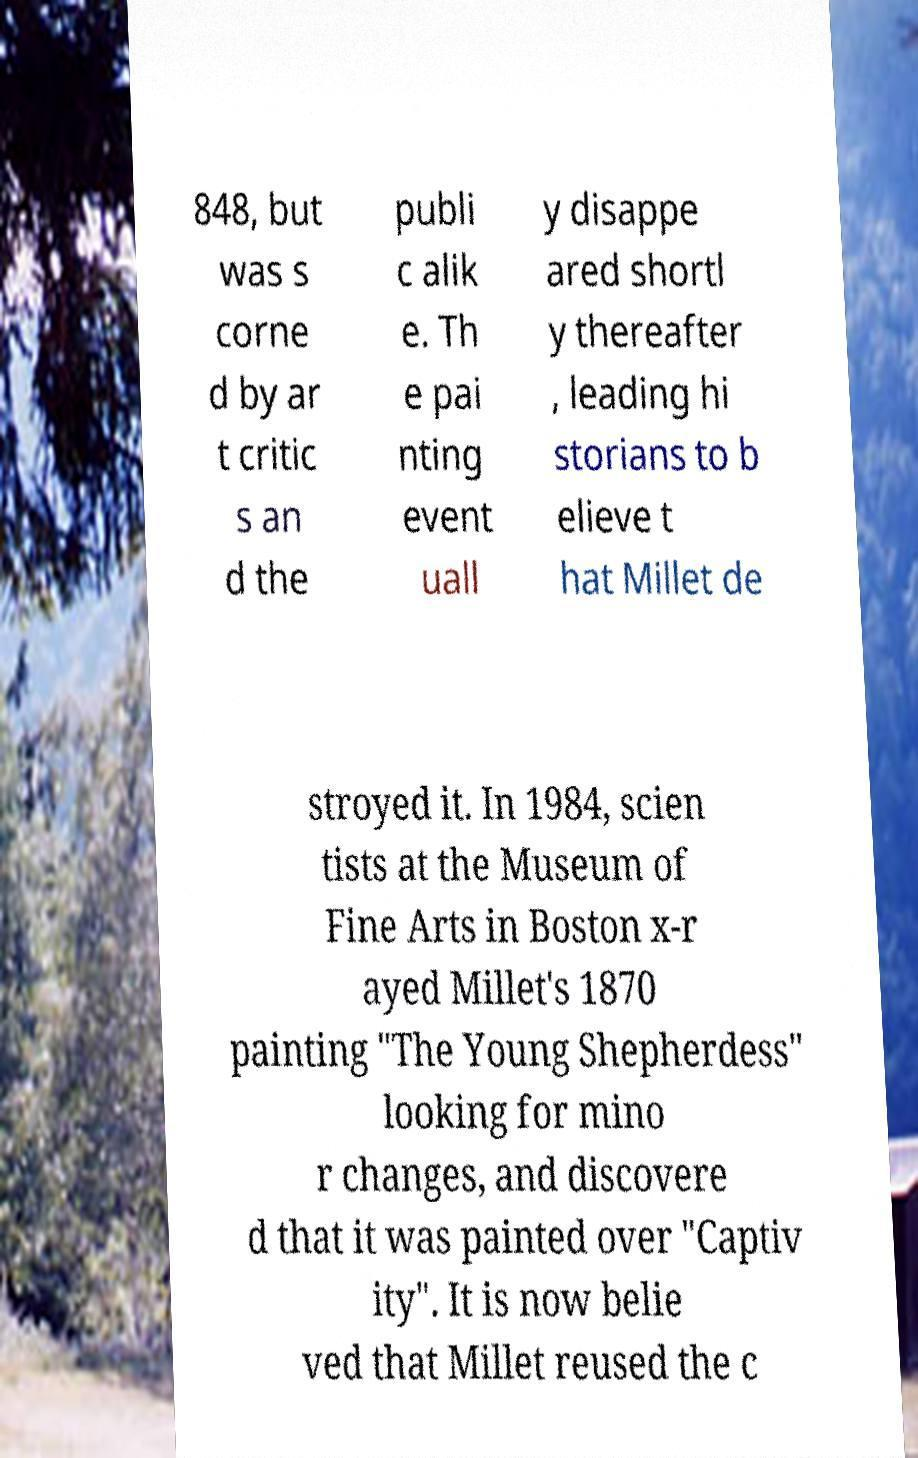I need the written content from this picture converted into text. Can you do that? 848, but was s corne d by ar t critic s an d the publi c alik e. Th e pai nting event uall y disappe ared shortl y thereafter , leading hi storians to b elieve t hat Millet de stroyed it. In 1984, scien tists at the Museum of Fine Arts in Boston x-r ayed Millet's 1870 painting "The Young Shepherdess" looking for mino r changes, and discovere d that it was painted over "Captiv ity". It is now belie ved that Millet reused the c 